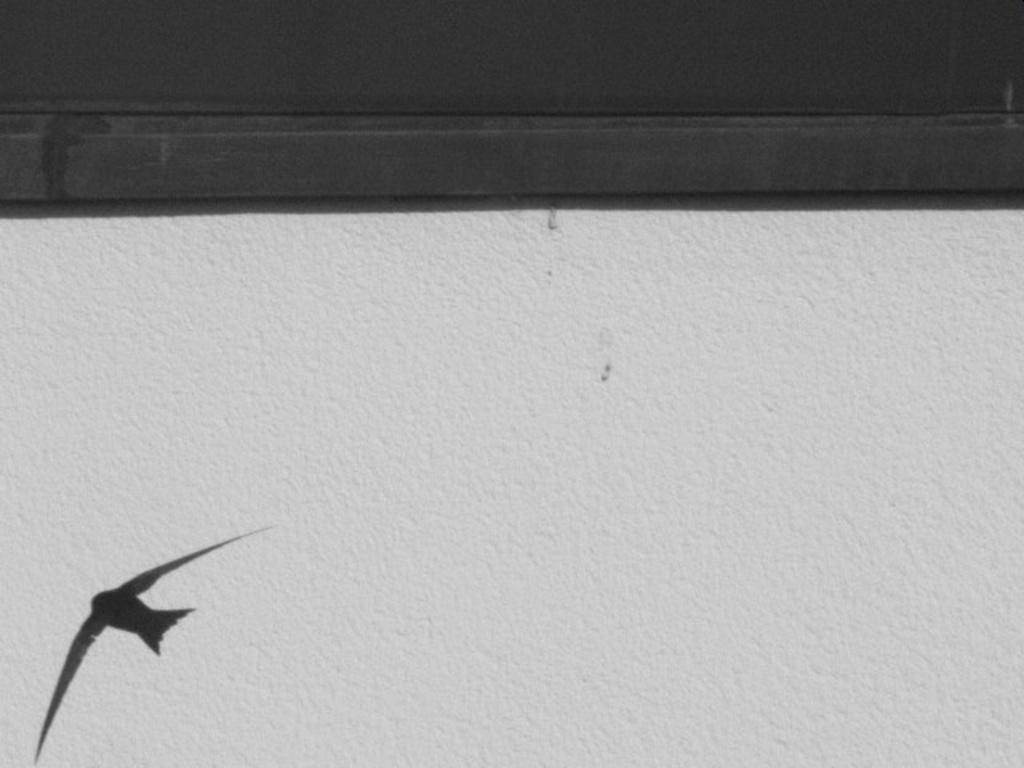What is present on the wall in the image? There is a painting of a bird on the wall. What type of border is visible on top of the wall? There is a black border on top of the wall. What type of prose is written on the wall in the image? There is no prose written on the wall in the image; it features a painting of a bird and a black border. 